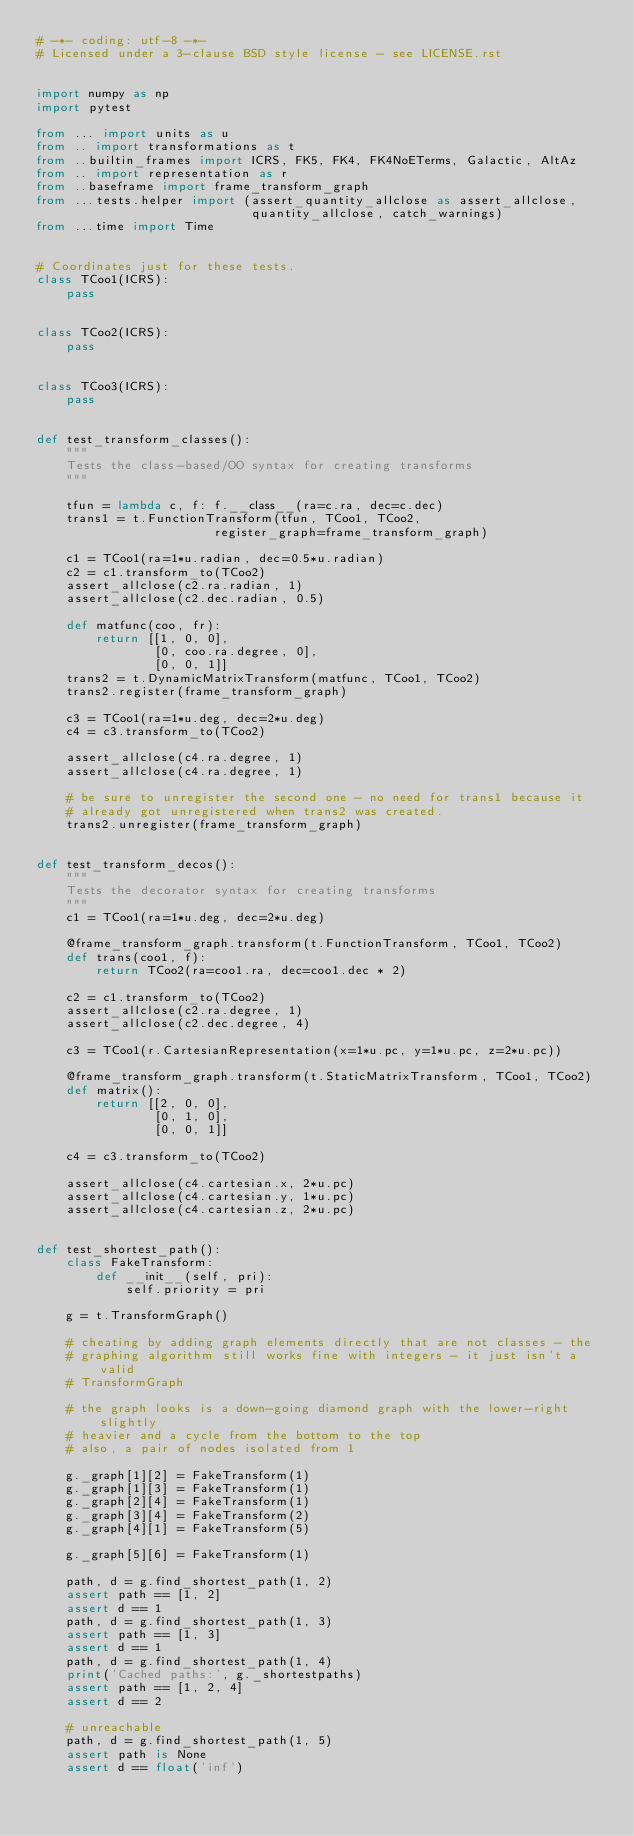<code> <loc_0><loc_0><loc_500><loc_500><_Python_># -*- coding: utf-8 -*-
# Licensed under a 3-clause BSD style license - see LICENSE.rst


import numpy as np
import pytest

from ... import units as u
from .. import transformations as t
from ..builtin_frames import ICRS, FK5, FK4, FK4NoETerms, Galactic, AltAz
from .. import representation as r
from ..baseframe import frame_transform_graph
from ...tests.helper import (assert_quantity_allclose as assert_allclose,
                             quantity_allclose, catch_warnings)
from ...time import Time


# Coordinates just for these tests.
class TCoo1(ICRS):
    pass


class TCoo2(ICRS):
    pass


class TCoo3(ICRS):
    pass


def test_transform_classes():
    """
    Tests the class-based/OO syntax for creating transforms
    """

    tfun = lambda c, f: f.__class__(ra=c.ra, dec=c.dec)
    trans1 = t.FunctionTransform(tfun, TCoo1, TCoo2,
                        register_graph=frame_transform_graph)

    c1 = TCoo1(ra=1*u.radian, dec=0.5*u.radian)
    c2 = c1.transform_to(TCoo2)
    assert_allclose(c2.ra.radian, 1)
    assert_allclose(c2.dec.radian, 0.5)

    def matfunc(coo, fr):
        return [[1, 0, 0],
                [0, coo.ra.degree, 0],
                [0, 0, 1]]
    trans2 = t.DynamicMatrixTransform(matfunc, TCoo1, TCoo2)
    trans2.register(frame_transform_graph)

    c3 = TCoo1(ra=1*u.deg, dec=2*u.deg)
    c4 = c3.transform_to(TCoo2)

    assert_allclose(c4.ra.degree, 1)
    assert_allclose(c4.ra.degree, 1)

    # be sure to unregister the second one - no need for trans1 because it
    # already got unregistered when trans2 was created.
    trans2.unregister(frame_transform_graph)


def test_transform_decos():
    """
    Tests the decorator syntax for creating transforms
    """
    c1 = TCoo1(ra=1*u.deg, dec=2*u.deg)

    @frame_transform_graph.transform(t.FunctionTransform, TCoo1, TCoo2)
    def trans(coo1, f):
        return TCoo2(ra=coo1.ra, dec=coo1.dec * 2)

    c2 = c1.transform_to(TCoo2)
    assert_allclose(c2.ra.degree, 1)
    assert_allclose(c2.dec.degree, 4)

    c3 = TCoo1(r.CartesianRepresentation(x=1*u.pc, y=1*u.pc, z=2*u.pc))

    @frame_transform_graph.transform(t.StaticMatrixTransform, TCoo1, TCoo2)
    def matrix():
        return [[2, 0, 0],
                [0, 1, 0],
                [0, 0, 1]]

    c4 = c3.transform_to(TCoo2)

    assert_allclose(c4.cartesian.x, 2*u.pc)
    assert_allclose(c4.cartesian.y, 1*u.pc)
    assert_allclose(c4.cartesian.z, 2*u.pc)


def test_shortest_path():
    class FakeTransform:
        def __init__(self, pri):
            self.priority = pri

    g = t.TransformGraph()

    # cheating by adding graph elements directly that are not classes - the
    # graphing algorithm still works fine with integers - it just isn't a valid
    # TransformGraph

    # the graph looks is a down-going diamond graph with the lower-right slightly
    # heavier and a cycle from the bottom to the top
    # also, a pair of nodes isolated from 1

    g._graph[1][2] = FakeTransform(1)
    g._graph[1][3] = FakeTransform(1)
    g._graph[2][4] = FakeTransform(1)
    g._graph[3][4] = FakeTransform(2)
    g._graph[4][1] = FakeTransform(5)

    g._graph[5][6] = FakeTransform(1)

    path, d = g.find_shortest_path(1, 2)
    assert path == [1, 2]
    assert d == 1
    path, d = g.find_shortest_path(1, 3)
    assert path == [1, 3]
    assert d == 1
    path, d = g.find_shortest_path(1, 4)
    print('Cached paths:', g._shortestpaths)
    assert path == [1, 2, 4]
    assert d == 2

    # unreachable
    path, d = g.find_shortest_path(1, 5)
    assert path is None
    assert d == float('inf')
</code> 